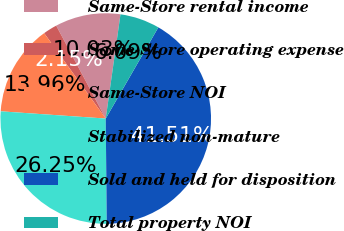Convert chart to OTSL. <chart><loc_0><loc_0><loc_500><loc_500><pie_chart><fcel>Same-Store rental income<fcel>Same-Store operating expense<fcel>Same-Store NOI<fcel>Stabilized non-mature<fcel>Sold and held for disposition<fcel>Total property NOI<nl><fcel>10.03%<fcel>2.15%<fcel>13.96%<fcel>26.25%<fcel>41.51%<fcel>6.09%<nl></chart> 